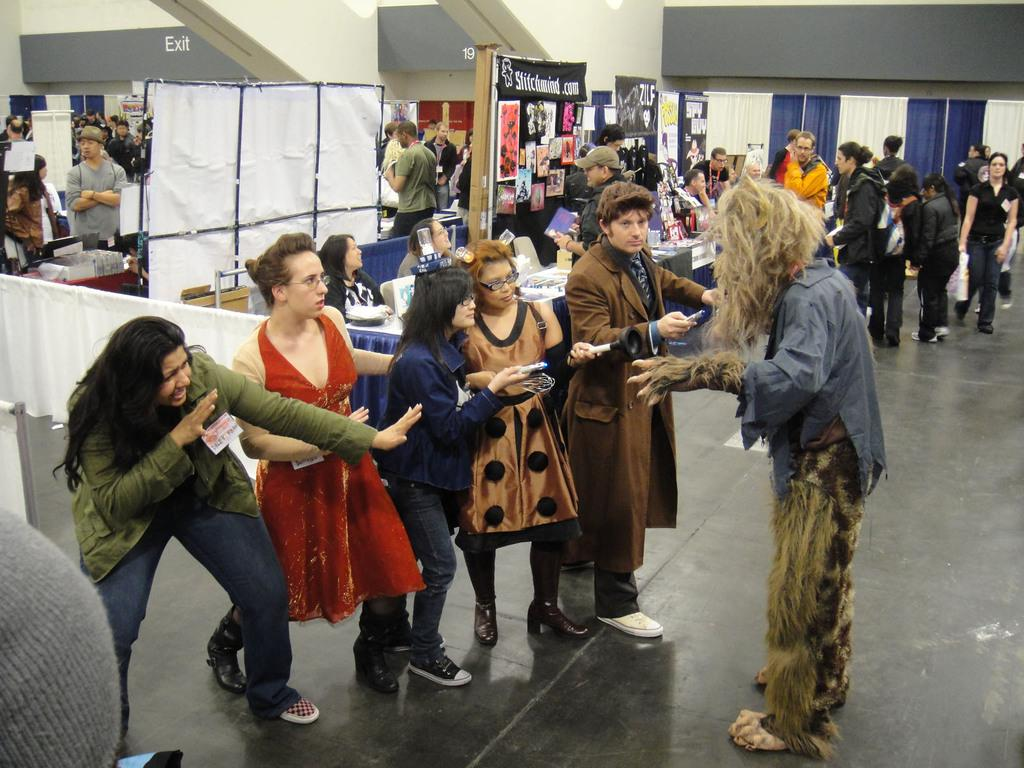What can be seen in the image involving human presence? There are people standing in the image. What type of decorations or advertisements are present in the image? There are posters in the image. What architectural element is visible in the image? There is a wall visible in the image. What type of window treatment is present in the image? There are curtains on the right side of the image. What book is being read by the person standing in the image? There is no book visible in the image, and it is not mentioned that anyone is reading. How many steps are present in the image? There is no mention of steps in the image, so it is impossible to determine their number. 